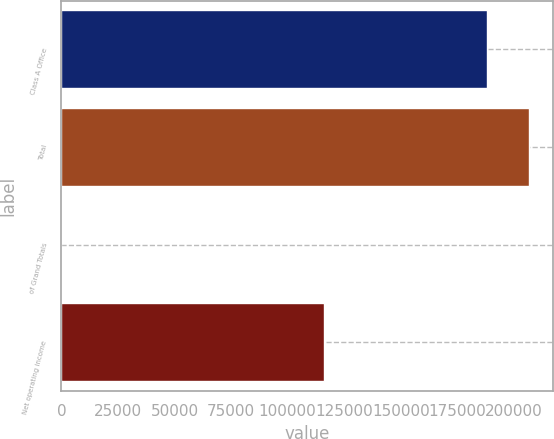Convert chart. <chart><loc_0><loc_0><loc_500><loc_500><bar_chart><fcel>Class A Office<fcel>Total<fcel>of Grand Totals<fcel>Net operating income<nl><fcel>188009<fcel>206809<fcel>13.81<fcel>116200<nl></chart> 